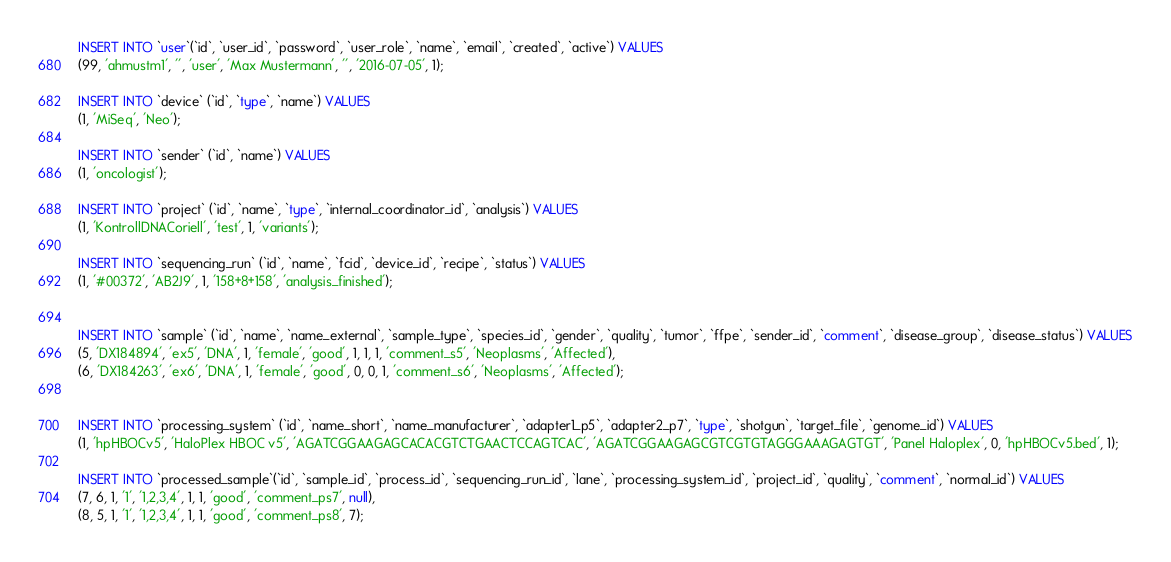<code> <loc_0><loc_0><loc_500><loc_500><_SQL_>INSERT INTO `user`(`id`, `user_id`, `password`, `user_role`, `name`, `email`, `created`, `active`) VALUES
(99, 'ahmustm1', '', 'user', 'Max Mustermann', '', '2016-07-05', 1);

INSERT INTO `device` (`id`, `type`, `name`) VALUES
(1, 'MiSeq', 'Neo');

INSERT INTO `sender` (`id`, `name`) VALUES
(1, 'oncologist');

INSERT INTO `project` (`id`, `name`, `type`, `internal_coordinator_id`, `analysis`) VALUES 
(1, 'KontrollDNACoriell', 'test', 1, 'variants');

INSERT INTO `sequencing_run` (`id`, `name`, `fcid`, `device_id`, `recipe`, `status`) VALUES
(1, '#00372', 'AB2J9', 1, '158+8+158', 'analysis_finished');


INSERT INTO `sample` (`id`, `name`, `name_external`, `sample_type`, `species_id`, `gender`, `quality`, `tumor`, `ffpe`, `sender_id`, `comment`, `disease_group`, `disease_status`) VALUES
(5, 'DX184894', 'ex5', 'DNA', 1, 'female', 'good', 1, 1, 1, 'comment_s5', 'Neoplasms', 'Affected'),
(6, 'DX184263', 'ex6', 'DNA', 1, 'female', 'good', 0, 0, 1, 'comment_s6', 'Neoplasms', 'Affected');


INSERT INTO `processing_system` (`id`, `name_short`, `name_manufacturer`, `adapter1_p5`, `adapter2_p7`, `type`, `shotgun`, `target_file`, `genome_id`) VALUES
(1, 'hpHBOCv5', 'HaloPlex HBOC v5', 'AGATCGGAAGAGCACACGTCTGAACTCCAGTCAC', 'AGATCGGAAGAGCGTCGTGTAGGGAAAGAGTGT', 'Panel Haloplex', 0, 'hpHBOCv5.bed', 1);

INSERT INTO `processed_sample`(`id`, `sample_id`, `process_id`, `sequencing_run_id`, `lane`, `processing_system_id`, `project_id`, `quality`, `comment`, `normal_id`) VALUES
(7, 6, 1, '1', '1,2,3,4', 1, 1, 'good', 'comment_ps7', null),
(8, 5, 1, '1', '1,2,3,4', 1, 1, 'good', 'comment_ps8', 7);</code> 